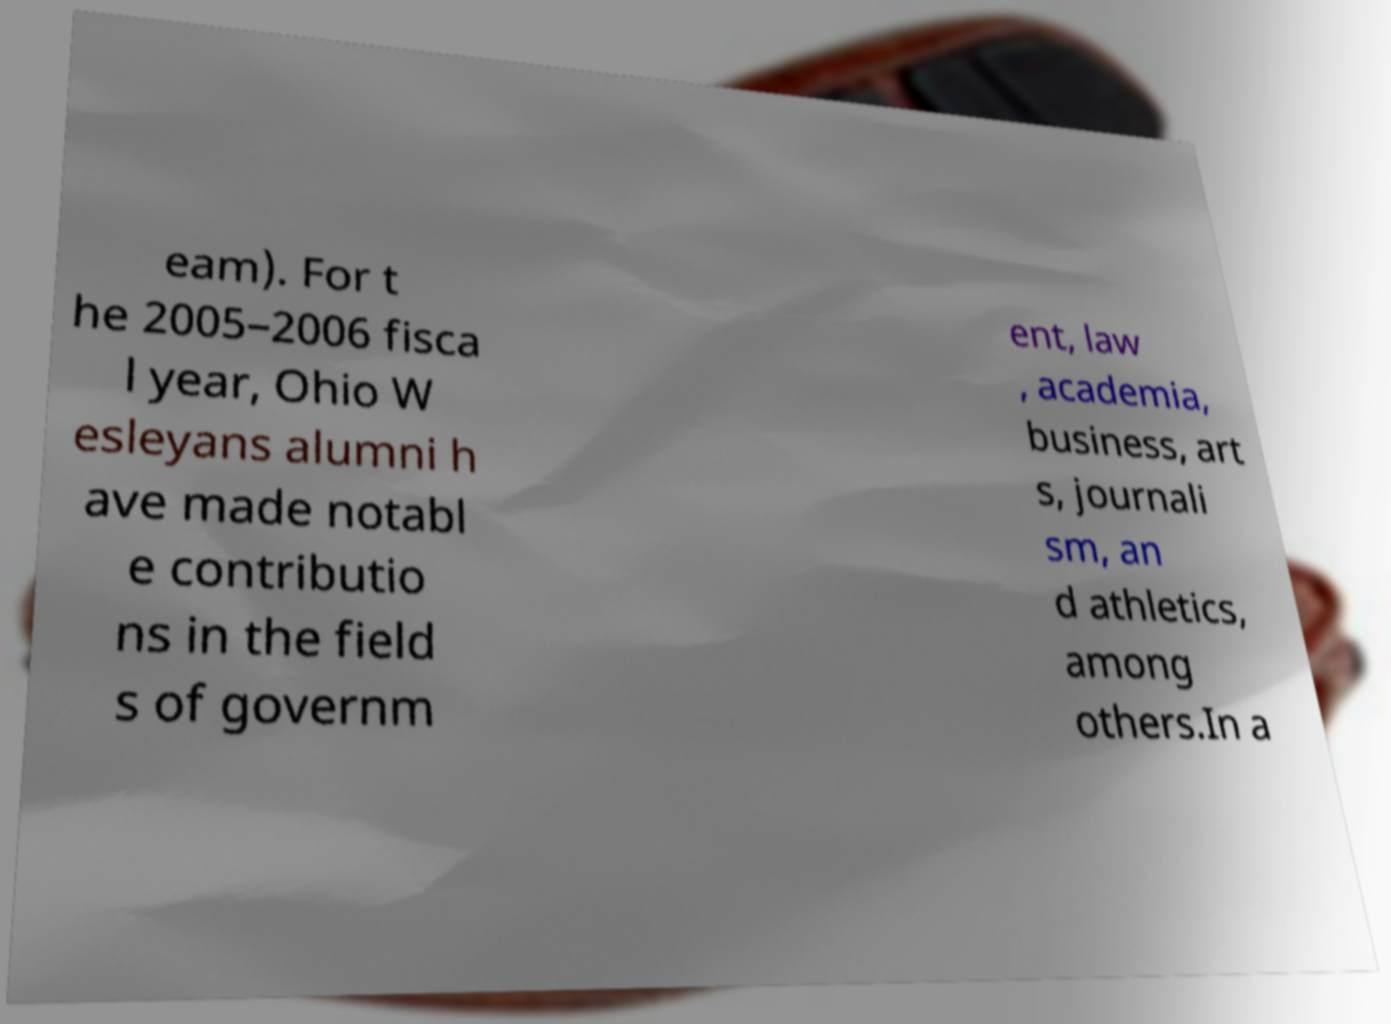Can you read and provide the text displayed in the image?This photo seems to have some interesting text. Can you extract and type it out for me? eam). For t he 2005–2006 fisca l year, Ohio W esleyans alumni h ave made notabl e contributio ns in the field s of governm ent, law , academia, business, art s, journali sm, an d athletics, among others.In a 